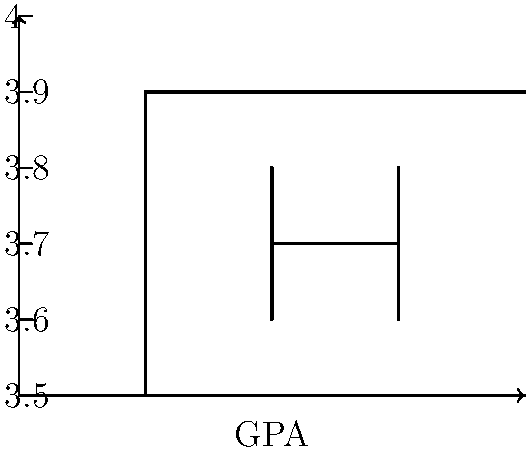A box-and-whisker plot shows the GPA distribution for Ivy League applicants. If the median GPA is 3.8 and the upper quartile is 3.9, what is the interquartile range (IQR) of the GPAs? To find the interquartile range (IQR), we need to follow these steps:

1. Identify the median (Q2) from the given information:
   $Q2 = 3.8$

2. Identify the upper quartile (Q3) from the given information:
   $Q3 = 3.9$

3. Determine the lower quartile (Q1) from the box plot:
   The box represents the middle 50% of the data, with Q1 at the bottom of the box and Q3 at the top.
   The distance from Q1 to Q2 is equal to the distance from Q2 to Q3.
   Therefore, $Q1 = Q2 - (Q3 - Q2) = 3.8 - (3.9 - 3.8) = 3.7$

4. Calculate the IQR using the formula:
   $IQR = Q3 - Q1$
   $IQR = 3.9 - 3.7 = 0.2$

The interquartile range represents the spread of the middle 50% of the data, which in this case is 0.2 GPA points.
Answer: 0.2 